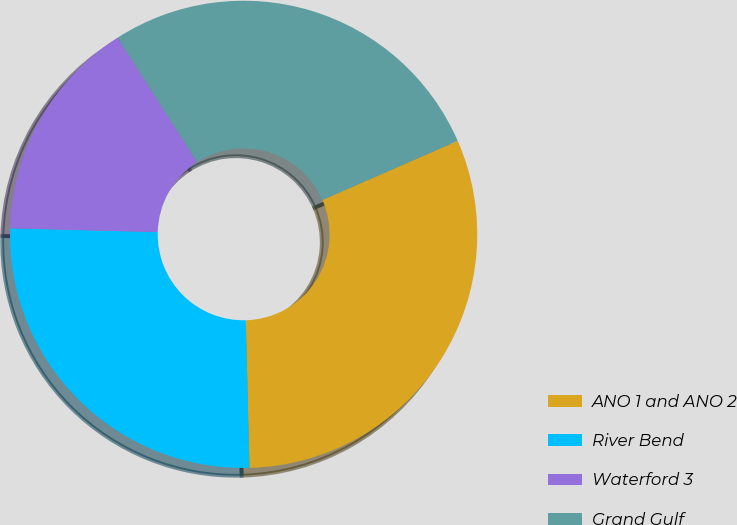Convert chart. <chart><loc_0><loc_0><loc_500><loc_500><pie_chart><fcel>ANO 1 and ANO 2<fcel>River Bend<fcel>Waterford 3<fcel>Grand Gulf<nl><fcel>31.16%<fcel>25.81%<fcel>15.52%<fcel>27.51%<nl></chart> 